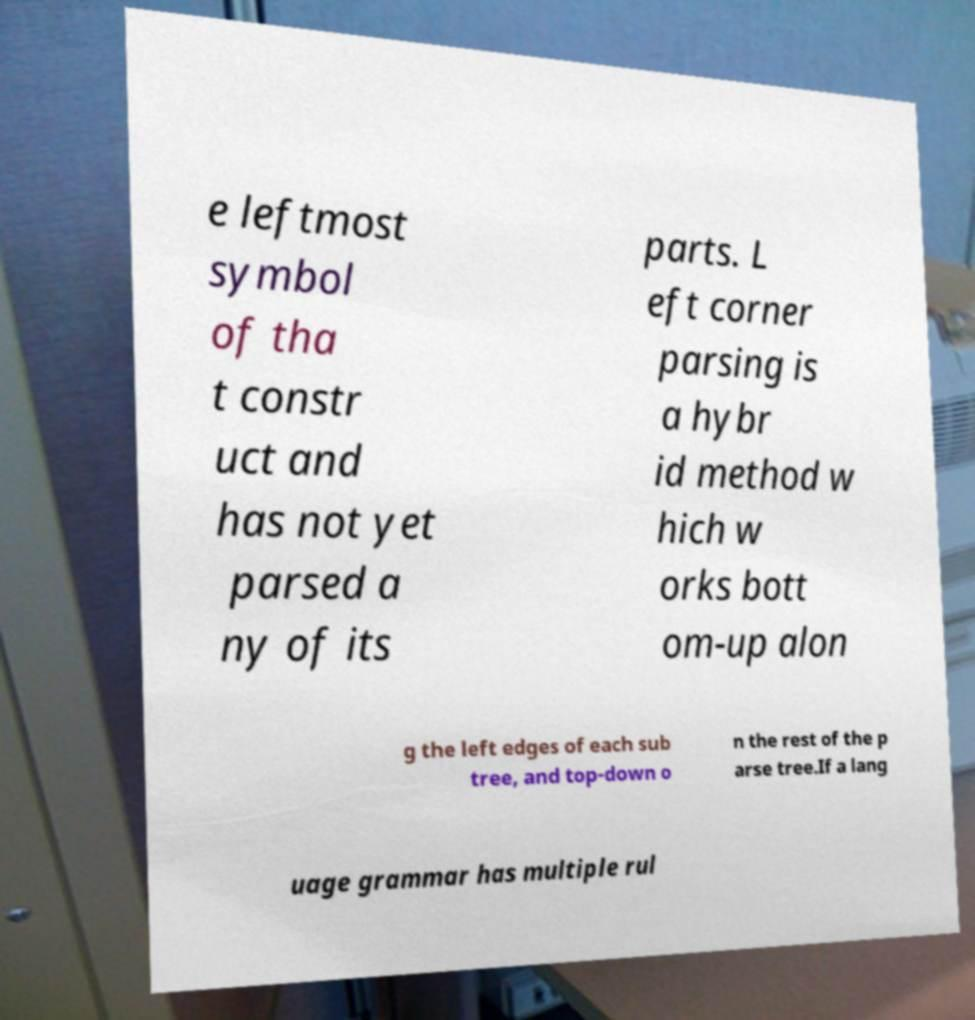There's text embedded in this image that I need extracted. Can you transcribe it verbatim? e leftmost symbol of tha t constr uct and has not yet parsed a ny of its parts. L eft corner parsing is a hybr id method w hich w orks bott om-up alon g the left edges of each sub tree, and top-down o n the rest of the p arse tree.If a lang uage grammar has multiple rul 